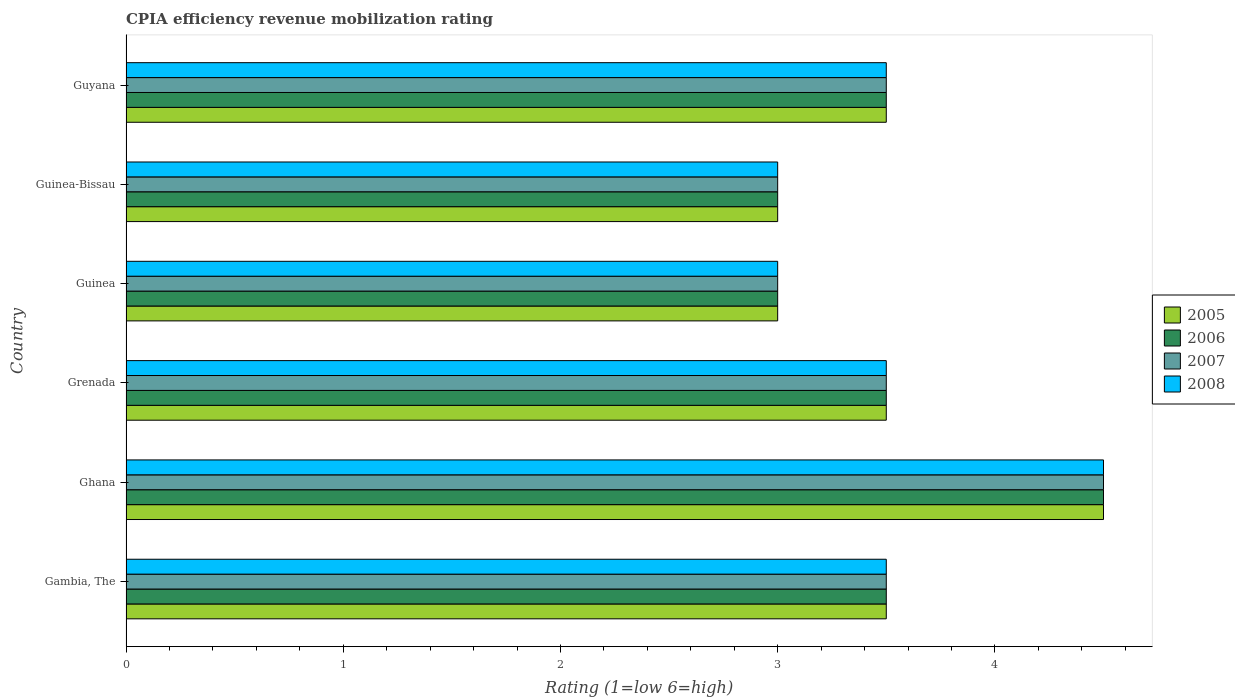How many groups of bars are there?
Your response must be concise. 6. Are the number of bars per tick equal to the number of legend labels?
Offer a terse response. Yes. How many bars are there on the 1st tick from the bottom?
Your answer should be compact. 4. What is the label of the 4th group of bars from the top?
Make the answer very short. Grenada. In how many cases, is the number of bars for a given country not equal to the number of legend labels?
Ensure brevity in your answer.  0. What is the CPIA rating in 2007 in Guinea-Bissau?
Keep it short and to the point. 3. Across all countries, what is the minimum CPIA rating in 2006?
Provide a short and direct response. 3. In which country was the CPIA rating in 2005 minimum?
Ensure brevity in your answer.  Guinea. What is the difference between the CPIA rating in 2005 in Gambia, The and that in Guinea?
Your answer should be very brief. 0.5. What is the difference between the CPIA rating in 2005 in Ghana and the CPIA rating in 2008 in Guinea-Bissau?
Provide a short and direct response. 1.5. What is the average CPIA rating in 2005 per country?
Give a very brief answer. 3.5. In how many countries, is the CPIA rating in 2006 greater than 3 ?
Offer a very short reply. 4. What is the ratio of the CPIA rating in 2008 in Ghana to that in Guinea-Bissau?
Make the answer very short. 1.5. What is the difference between the highest and the lowest CPIA rating in 2007?
Make the answer very short. 1.5. Is the sum of the CPIA rating in 2006 in Ghana and Guinea-Bissau greater than the maximum CPIA rating in 2007 across all countries?
Your response must be concise. Yes. Is it the case that in every country, the sum of the CPIA rating in 2008 and CPIA rating in 2007 is greater than the sum of CPIA rating in 2006 and CPIA rating in 2005?
Your answer should be compact. No. What does the 3rd bar from the bottom in Gambia, The represents?
Keep it short and to the point. 2007. Is it the case that in every country, the sum of the CPIA rating in 2007 and CPIA rating in 2008 is greater than the CPIA rating in 2006?
Provide a short and direct response. Yes. How many countries are there in the graph?
Keep it short and to the point. 6. What is the difference between two consecutive major ticks on the X-axis?
Offer a terse response. 1. Where does the legend appear in the graph?
Offer a very short reply. Center right. How many legend labels are there?
Ensure brevity in your answer.  4. How are the legend labels stacked?
Ensure brevity in your answer.  Vertical. What is the title of the graph?
Offer a very short reply. CPIA efficiency revenue mobilization rating. What is the Rating (1=low 6=high) of 2007 in Gambia, The?
Keep it short and to the point. 3.5. What is the Rating (1=low 6=high) of 2005 in Ghana?
Give a very brief answer. 4.5. What is the Rating (1=low 6=high) in 2006 in Ghana?
Offer a very short reply. 4.5. What is the Rating (1=low 6=high) in 2008 in Ghana?
Give a very brief answer. 4.5. What is the Rating (1=low 6=high) of 2005 in Grenada?
Offer a terse response. 3.5. What is the Rating (1=low 6=high) in 2006 in Grenada?
Provide a short and direct response. 3.5. What is the Rating (1=low 6=high) in 2005 in Guinea?
Your answer should be very brief. 3. What is the Rating (1=low 6=high) of 2006 in Guinea?
Your answer should be very brief. 3. What is the Rating (1=low 6=high) of 2007 in Guinea?
Keep it short and to the point. 3. What is the Rating (1=low 6=high) in 2007 in Guinea-Bissau?
Provide a succinct answer. 3. Across all countries, what is the maximum Rating (1=low 6=high) in 2006?
Offer a terse response. 4.5. Across all countries, what is the maximum Rating (1=low 6=high) of 2007?
Your response must be concise. 4.5. Across all countries, what is the maximum Rating (1=low 6=high) in 2008?
Ensure brevity in your answer.  4.5. Across all countries, what is the minimum Rating (1=low 6=high) in 2006?
Keep it short and to the point. 3. Across all countries, what is the minimum Rating (1=low 6=high) in 2008?
Give a very brief answer. 3. What is the total Rating (1=low 6=high) of 2005 in the graph?
Your response must be concise. 21. What is the total Rating (1=low 6=high) in 2007 in the graph?
Make the answer very short. 21. What is the difference between the Rating (1=low 6=high) in 2006 in Gambia, The and that in Ghana?
Make the answer very short. -1. What is the difference between the Rating (1=low 6=high) of 2008 in Gambia, The and that in Ghana?
Make the answer very short. -1. What is the difference between the Rating (1=low 6=high) of 2006 in Gambia, The and that in Grenada?
Offer a very short reply. 0. What is the difference between the Rating (1=low 6=high) in 2007 in Gambia, The and that in Grenada?
Your answer should be very brief. 0. What is the difference between the Rating (1=low 6=high) in 2008 in Gambia, The and that in Grenada?
Give a very brief answer. 0. What is the difference between the Rating (1=low 6=high) in 2006 in Gambia, The and that in Guinea?
Make the answer very short. 0.5. What is the difference between the Rating (1=low 6=high) in 2007 in Gambia, The and that in Guinea?
Your response must be concise. 0.5. What is the difference between the Rating (1=low 6=high) in 2005 in Gambia, The and that in Guinea-Bissau?
Offer a terse response. 0.5. What is the difference between the Rating (1=low 6=high) of 2005 in Gambia, The and that in Guyana?
Provide a short and direct response. 0. What is the difference between the Rating (1=low 6=high) in 2006 in Gambia, The and that in Guyana?
Keep it short and to the point. 0. What is the difference between the Rating (1=low 6=high) in 2005 in Ghana and that in Grenada?
Provide a short and direct response. 1. What is the difference between the Rating (1=low 6=high) in 2007 in Ghana and that in Guinea?
Offer a very short reply. 1.5. What is the difference between the Rating (1=low 6=high) in 2005 in Ghana and that in Guinea-Bissau?
Provide a succinct answer. 1.5. What is the difference between the Rating (1=low 6=high) in 2008 in Ghana and that in Guinea-Bissau?
Your answer should be compact. 1.5. What is the difference between the Rating (1=low 6=high) in 2005 in Ghana and that in Guyana?
Offer a terse response. 1. What is the difference between the Rating (1=low 6=high) in 2007 in Ghana and that in Guyana?
Ensure brevity in your answer.  1. What is the difference between the Rating (1=low 6=high) of 2005 in Grenada and that in Guinea?
Offer a very short reply. 0.5. What is the difference between the Rating (1=low 6=high) in 2008 in Grenada and that in Guinea-Bissau?
Offer a very short reply. 0.5. What is the difference between the Rating (1=low 6=high) in 2005 in Grenada and that in Guyana?
Give a very brief answer. 0. What is the difference between the Rating (1=low 6=high) of 2006 in Grenada and that in Guyana?
Provide a succinct answer. 0. What is the difference between the Rating (1=low 6=high) of 2005 in Guinea and that in Guinea-Bissau?
Ensure brevity in your answer.  0. What is the difference between the Rating (1=low 6=high) in 2006 in Guinea and that in Guinea-Bissau?
Give a very brief answer. 0. What is the difference between the Rating (1=low 6=high) of 2007 in Guinea and that in Guinea-Bissau?
Provide a succinct answer. 0. What is the difference between the Rating (1=low 6=high) in 2005 in Guinea-Bissau and that in Guyana?
Your response must be concise. -0.5. What is the difference between the Rating (1=low 6=high) in 2008 in Guinea-Bissau and that in Guyana?
Your answer should be very brief. -0.5. What is the difference between the Rating (1=low 6=high) in 2005 in Gambia, The and the Rating (1=low 6=high) in 2008 in Ghana?
Your answer should be compact. -1. What is the difference between the Rating (1=low 6=high) of 2006 in Gambia, The and the Rating (1=low 6=high) of 2008 in Ghana?
Offer a very short reply. -1. What is the difference between the Rating (1=low 6=high) of 2007 in Gambia, The and the Rating (1=low 6=high) of 2008 in Ghana?
Ensure brevity in your answer.  -1. What is the difference between the Rating (1=low 6=high) of 2005 in Gambia, The and the Rating (1=low 6=high) of 2007 in Grenada?
Provide a succinct answer. 0. What is the difference between the Rating (1=low 6=high) in 2006 in Gambia, The and the Rating (1=low 6=high) in 2008 in Grenada?
Your answer should be compact. 0. What is the difference between the Rating (1=low 6=high) of 2007 in Gambia, The and the Rating (1=low 6=high) of 2008 in Grenada?
Make the answer very short. 0. What is the difference between the Rating (1=low 6=high) of 2005 in Gambia, The and the Rating (1=low 6=high) of 2007 in Guinea?
Provide a succinct answer. 0.5. What is the difference between the Rating (1=low 6=high) of 2005 in Gambia, The and the Rating (1=low 6=high) of 2008 in Guinea?
Ensure brevity in your answer.  0.5. What is the difference between the Rating (1=low 6=high) in 2006 in Gambia, The and the Rating (1=low 6=high) in 2007 in Guinea?
Provide a succinct answer. 0.5. What is the difference between the Rating (1=low 6=high) in 2007 in Gambia, The and the Rating (1=low 6=high) in 2008 in Guinea?
Offer a terse response. 0.5. What is the difference between the Rating (1=low 6=high) in 2005 in Gambia, The and the Rating (1=low 6=high) in 2006 in Guinea-Bissau?
Your answer should be compact. 0.5. What is the difference between the Rating (1=low 6=high) of 2005 in Gambia, The and the Rating (1=low 6=high) of 2007 in Guinea-Bissau?
Offer a terse response. 0.5. What is the difference between the Rating (1=low 6=high) of 2006 in Gambia, The and the Rating (1=low 6=high) of 2007 in Guinea-Bissau?
Ensure brevity in your answer.  0.5. What is the difference between the Rating (1=low 6=high) of 2005 in Gambia, The and the Rating (1=low 6=high) of 2007 in Guyana?
Provide a succinct answer. 0. What is the difference between the Rating (1=low 6=high) of 2005 in Gambia, The and the Rating (1=low 6=high) of 2008 in Guyana?
Offer a terse response. 0. What is the difference between the Rating (1=low 6=high) in 2006 in Gambia, The and the Rating (1=low 6=high) in 2008 in Guyana?
Offer a terse response. 0. What is the difference between the Rating (1=low 6=high) of 2005 in Ghana and the Rating (1=low 6=high) of 2006 in Grenada?
Make the answer very short. 1. What is the difference between the Rating (1=low 6=high) of 2005 in Ghana and the Rating (1=low 6=high) of 2007 in Grenada?
Make the answer very short. 1. What is the difference between the Rating (1=low 6=high) in 2005 in Ghana and the Rating (1=low 6=high) in 2008 in Grenada?
Your answer should be very brief. 1. What is the difference between the Rating (1=low 6=high) of 2005 in Ghana and the Rating (1=low 6=high) of 2008 in Guinea?
Offer a terse response. 1.5. What is the difference between the Rating (1=low 6=high) in 2007 in Ghana and the Rating (1=low 6=high) in 2008 in Guinea?
Your answer should be compact. 1.5. What is the difference between the Rating (1=low 6=high) of 2006 in Ghana and the Rating (1=low 6=high) of 2008 in Guinea-Bissau?
Offer a terse response. 1.5. What is the difference between the Rating (1=low 6=high) of 2006 in Ghana and the Rating (1=low 6=high) of 2007 in Guyana?
Keep it short and to the point. 1. What is the difference between the Rating (1=low 6=high) of 2005 in Grenada and the Rating (1=low 6=high) of 2008 in Guinea?
Make the answer very short. 0.5. What is the difference between the Rating (1=low 6=high) of 2005 in Grenada and the Rating (1=low 6=high) of 2006 in Guinea-Bissau?
Your answer should be very brief. 0.5. What is the difference between the Rating (1=low 6=high) of 2005 in Grenada and the Rating (1=low 6=high) of 2008 in Guinea-Bissau?
Give a very brief answer. 0.5. What is the difference between the Rating (1=low 6=high) in 2006 in Grenada and the Rating (1=low 6=high) in 2008 in Guinea-Bissau?
Offer a very short reply. 0.5. What is the difference between the Rating (1=low 6=high) of 2005 in Grenada and the Rating (1=low 6=high) of 2006 in Guyana?
Offer a terse response. 0. What is the difference between the Rating (1=low 6=high) in 2005 in Grenada and the Rating (1=low 6=high) in 2008 in Guyana?
Offer a terse response. 0. What is the difference between the Rating (1=low 6=high) in 2006 in Grenada and the Rating (1=low 6=high) in 2007 in Guyana?
Provide a short and direct response. 0. What is the difference between the Rating (1=low 6=high) of 2005 in Guinea and the Rating (1=low 6=high) of 2008 in Guinea-Bissau?
Provide a succinct answer. 0. What is the difference between the Rating (1=low 6=high) of 2006 in Guinea and the Rating (1=low 6=high) of 2008 in Guinea-Bissau?
Keep it short and to the point. 0. What is the difference between the Rating (1=low 6=high) in 2005 in Guinea and the Rating (1=low 6=high) in 2006 in Guyana?
Keep it short and to the point. -0.5. What is the difference between the Rating (1=low 6=high) of 2007 in Guinea and the Rating (1=low 6=high) of 2008 in Guyana?
Make the answer very short. -0.5. What is the difference between the Rating (1=low 6=high) in 2005 in Guinea-Bissau and the Rating (1=low 6=high) in 2008 in Guyana?
Provide a succinct answer. -0.5. What is the difference between the Rating (1=low 6=high) in 2006 in Guinea-Bissau and the Rating (1=low 6=high) in 2007 in Guyana?
Offer a very short reply. -0.5. What is the difference between the Rating (1=low 6=high) in 2006 in Guinea-Bissau and the Rating (1=low 6=high) in 2008 in Guyana?
Make the answer very short. -0.5. What is the difference between the Rating (1=low 6=high) of 2007 in Guinea-Bissau and the Rating (1=low 6=high) of 2008 in Guyana?
Provide a short and direct response. -0.5. What is the average Rating (1=low 6=high) of 2007 per country?
Your answer should be compact. 3.5. What is the difference between the Rating (1=low 6=high) in 2005 and Rating (1=low 6=high) in 2007 in Gambia, The?
Your answer should be very brief. 0. What is the difference between the Rating (1=low 6=high) of 2005 and Rating (1=low 6=high) of 2008 in Gambia, The?
Offer a very short reply. 0. What is the difference between the Rating (1=low 6=high) in 2006 and Rating (1=low 6=high) in 2008 in Gambia, The?
Your answer should be compact. 0. What is the difference between the Rating (1=low 6=high) of 2005 and Rating (1=low 6=high) of 2006 in Ghana?
Your answer should be very brief. 0. What is the difference between the Rating (1=low 6=high) in 2005 and Rating (1=low 6=high) in 2007 in Ghana?
Provide a succinct answer. 0. What is the difference between the Rating (1=low 6=high) of 2005 and Rating (1=low 6=high) of 2008 in Ghana?
Ensure brevity in your answer.  0. What is the difference between the Rating (1=low 6=high) of 2006 and Rating (1=low 6=high) of 2008 in Ghana?
Make the answer very short. 0. What is the difference between the Rating (1=low 6=high) in 2007 and Rating (1=low 6=high) in 2008 in Ghana?
Provide a short and direct response. 0. What is the difference between the Rating (1=low 6=high) in 2005 and Rating (1=low 6=high) in 2006 in Grenada?
Give a very brief answer. 0. What is the difference between the Rating (1=low 6=high) in 2005 and Rating (1=low 6=high) in 2007 in Grenada?
Make the answer very short. 0. What is the difference between the Rating (1=low 6=high) in 2005 and Rating (1=low 6=high) in 2008 in Grenada?
Ensure brevity in your answer.  0. What is the difference between the Rating (1=low 6=high) of 2006 and Rating (1=low 6=high) of 2008 in Grenada?
Offer a very short reply. 0. What is the difference between the Rating (1=low 6=high) in 2007 and Rating (1=low 6=high) in 2008 in Grenada?
Keep it short and to the point. 0. What is the difference between the Rating (1=low 6=high) in 2005 and Rating (1=low 6=high) in 2006 in Guinea?
Offer a very short reply. 0. What is the difference between the Rating (1=low 6=high) of 2005 and Rating (1=low 6=high) of 2007 in Guinea?
Your response must be concise. 0. What is the difference between the Rating (1=low 6=high) in 2005 and Rating (1=low 6=high) in 2008 in Guinea?
Offer a terse response. 0. What is the difference between the Rating (1=low 6=high) in 2006 and Rating (1=low 6=high) in 2007 in Guinea?
Your answer should be compact. 0. What is the difference between the Rating (1=low 6=high) of 2006 and Rating (1=low 6=high) of 2008 in Guinea?
Keep it short and to the point. 0. What is the difference between the Rating (1=low 6=high) of 2007 and Rating (1=low 6=high) of 2008 in Guinea?
Your response must be concise. 0. What is the difference between the Rating (1=low 6=high) in 2005 and Rating (1=low 6=high) in 2008 in Guinea-Bissau?
Ensure brevity in your answer.  0. What is the difference between the Rating (1=low 6=high) in 2007 and Rating (1=low 6=high) in 2008 in Guinea-Bissau?
Offer a terse response. 0. What is the difference between the Rating (1=low 6=high) in 2005 and Rating (1=low 6=high) in 2007 in Guyana?
Keep it short and to the point. 0. What is the difference between the Rating (1=low 6=high) in 2006 and Rating (1=low 6=high) in 2008 in Guyana?
Your response must be concise. 0. What is the difference between the Rating (1=low 6=high) of 2007 and Rating (1=low 6=high) of 2008 in Guyana?
Offer a very short reply. 0. What is the ratio of the Rating (1=low 6=high) in 2007 in Gambia, The to that in Ghana?
Your response must be concise. 0.78. What is the ratio of the Rating (1=low 6=high) of 2008 in Gambia, The to that in Grenada?
Provide a short and direct response. 1. What is the ratio of the Rating (1=low 6=high) of 2006 in Gambia, The to that in Guinea?
Your response must be concise. 1.17. What is the ratio of the Rating (1=low 6=high) in 2007 in Gambia, The to that in Guinea?
Ensure brevity in your answer.  1.17. What is the ratio of the Rating (1=low 6=high) of 2006 in Gambia, The to that in Guinea-Bissau?
Make the answer very short. 1.17. What is the ratio of the Rating (1=low 6=high) in 2008 in Gambia, The to that in Guinea-Bissau?
Make the answer very short. 1.17. What is the ratio of the Rating (1=low 6=high) of 2005 in Gambia, The to that in Guyana?
Provide a succinct answer. 1. What is the ratio of the Rating (1=low 6=high) in 2006 in Gambia, The to that in Guyana?
Provide a short and direct response. 1. What is the ratio of the Rating (1=low 6=high) of 2008 in Gambia, The to that in Guyana?
Your answer should be compact. 1. What is the ratio of the Rating (1=low 6=high) of 2006 in Ghana to that in Grenada?
Your answer should be very brief. 1.29. What is the ratio of the Rating (1=low 6=high) in 2008 in Ghana to that in Grenada?
Your answer should be very brief. 1.29. What is the ratio of the Rating (1=low 6=high) of 2005 in Ghana to that in Guinea-Bissau?
Offer a very short reply. 1.5. What is the ratio of the Rating (1=low 6=high) of 2006 in Ghana to that in Guinea-Bissau?
Offer a very short reply. 1.5. What is the ratio of the Rating (1=low 6=high) in 2005 in Ghana to that in Guyana?
Provide a succinct answer. 1.29. What is the ratio of the Rating (1=low 6=high) in 2006 in Ghana to that in Guyana?
Offer a terse response. 1.29. What is the ratio of the Rating (1=low 6=high) in 2007 in Ghana to that in Guyana?
Offer a terse response. 1.29. What is the ratio of the Rating (1=low 6=high) in 2008 in Grenada to that in Guinea?
Your answer should be very brief. 1.17. What is the ratio of the Rating (1=low 6=high) in 2005 in Grenada to that in Guinea-Bissau?
Provide a short and direct response. 1.17. What is the ratio of the Rating (1=low 6=high) of 2006 in Grenada to that in Guinea-Bissau?
Offer a terse response. 1.17. What is the ratio of the Rating (1=low 6=high) of 2007 in Grenada to that in Guinea-Bissau?
Make the answer very short. 1.17. What is the ratio of the Rating (1=low 6=high) of 2008 in Grenada to that in Guinea-Bissau?
Offer a very short reply. 1.17. What is the ratio of the Rating (1=low 6=high) in 2008 in Grenada to that in Guyana?
Your answer should be compact. 1. What is the ratio of the Rating (1=low 6=high) in 2005 in Guinea to that in Guinea-Bissau?
Provide a succinct answer. 1. What is the ratio of the Rating (1=low 6=high) of 2006 in Guinea to that in Guinea-Bissau?
Make the answer very short. 1. What is the ratio of the Rating (1=low 6=high) of 2008 in Guinea to that in Guinea-Bissau?
Make the answer very short. 1. What is the ratio of the Rating (1=low 6=high) of 2005 in Guinea to that in Guyana?
Your response must be concise. 0.86. What is the ratio of the Rating (1=low 6=high) in 2006 in Guinea to that in Guyana?
Provide a succinct answer. 0.86. What is the ratio of the Rating (1=low 6=high) in 2006 in Guinea-Bissau to that in Guyana?
Give a very brief answer. 0.86. What is the difference between the highest and the second highest Rating (1=low 6=high) in 2005?
Your response must be concise. 1. What is the difference between the highest and the second highest Rating (1=low 6=high) in 2007?
Keep it short and to the point. 1. What is the difference between the highest and the second highest Rating (1=low 6=high) of 2008?
Your answer should be compact. 1. What is the difference between the highest and the lowest Rating (1=low 6=high) in 2006?
Offer a terse response. 1.5. 